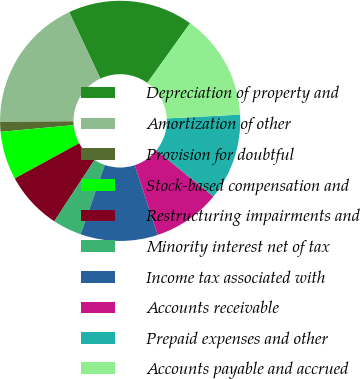Convert chart to OTSL. <chart><loc_0><loc_0><loc_500><loc_500><pie_chart><fcel>Depreciation of property and<fcel>Amortization of other<fcel>Provision for doubtful<fcel>Stock-based compensation and<fcel>Restructuring impairments and<fcel>Minority interest net of tax<fcel>Income tax associated with<fcel>Accounts receivable<fcel>Prepaid expenses and other<fcel>Accounts payable and accrued<nl><fcel>16.87%<fcel>18.16%<fcel>1.32%<fcel>6.5%<fcel>7.8%<fcel>3.91%<fcel>10.39%<fcel>9.09%<fcel>11.68%<fcel>14.28%<nl></chart> 